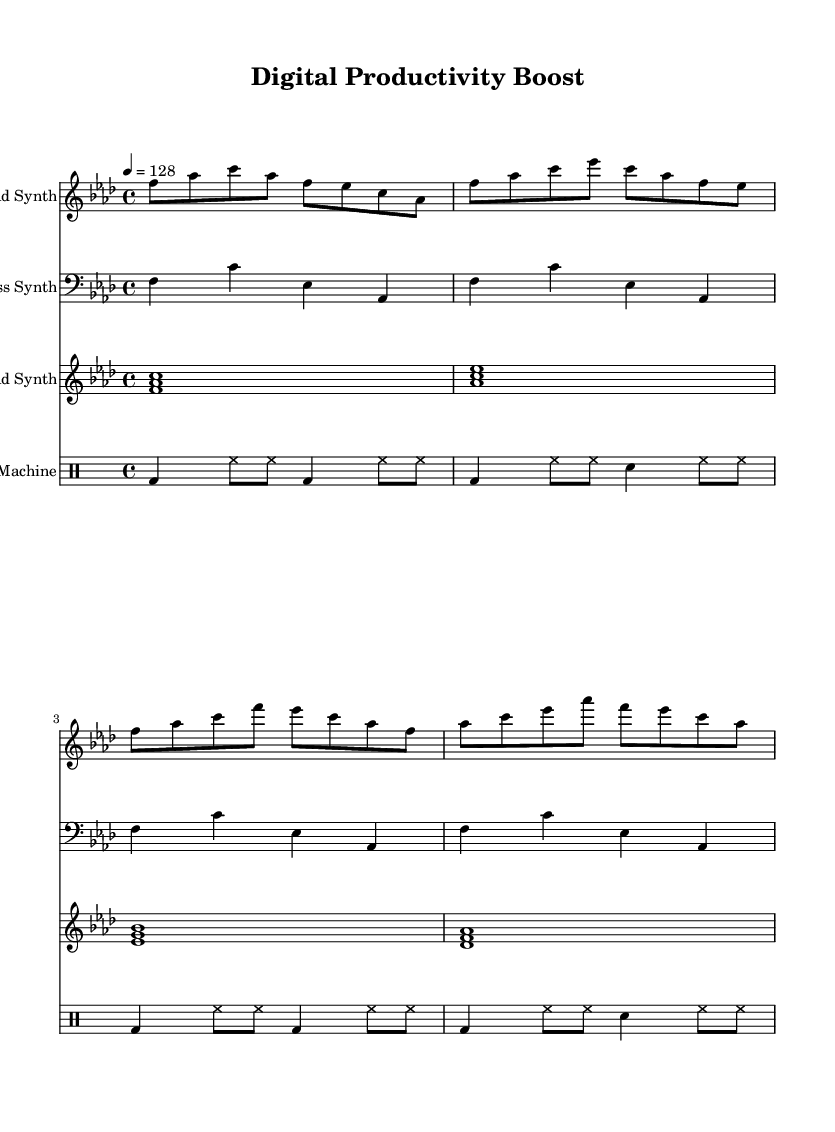What is the key signature of this music? The key signature indicated is F minor, which has four flats (B♭, E♭, A♭, and D♭). It is found at the beginning of the staff, showing the arrangement of flats.
Answer: F minor What is the time signature of this music? The time signature is 4/4, which means there are four beats in each measure and the quarter note gets one beat. This is displayed at the start of the piece, indicating the rhythmic structure.
Answer: 4/4 What is the tempo marking for this music? The tempo marking is 128 beats per minute, indicated at the beginning of the score. It tells us the speed at which the music should be played and is written as “4 = 128”.
Answer: 128 How many measures are in the lead synth part? The lead synth part consists of four measures, as each group of notes is separated by a bar line, and the first synth staff contains notes across four distinct measure lines.
Answer: 4 Which instrument has a clef indicating bass notes? The bass synth, which uses the bass clef, is designed for lower pitches, and its staff is labeled accordingly. The clef is positioned at the beginning of the bass synth staff, indicating this role.
Answer: Bass Synth What type of synthesizer is highlighted for the sustained chords? The pad synth is specifically designed for sustained chords, as indicated in the music sheet by the chord notation written at the beginning of its staff, showing layered notes played together.
Answer: Pad Synth How is the drum pattern structured according to the beats? The drum pattern follows a consistent structure alternating between kick drum (bd) and hi-hat (hh), with snare (sn) added in certain measures, revealing a typical house rhythm across four measures.
Answer: Alternating pattern 